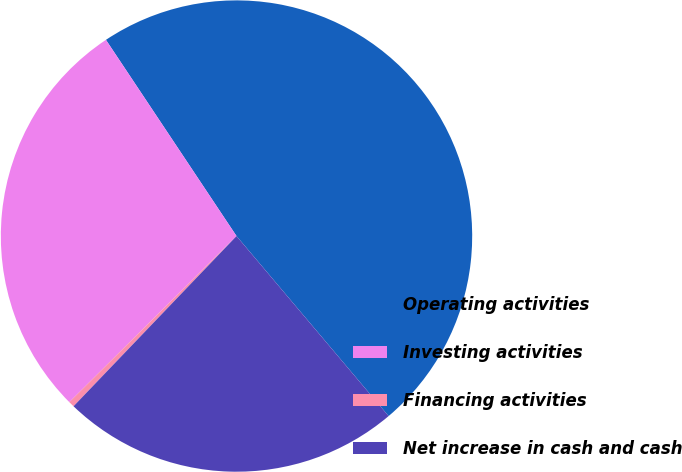Convert chart. <chart><loc_0><loc_0><loc_500><loc_500><pie_chart><fcel>Operating activities<fcel>Investing activities<fcel>Financing activities<fcel>Net increase in cash and cash<nl><fcel>48.18%<fcel>28.1%<fcel>0.4%<fcel>23.32%<nl></chart> 